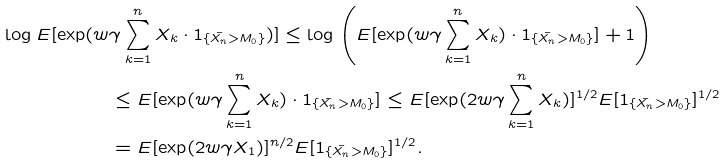Convert formula to latex. <formula><loc_0><loc_0><loc_500><loc_500>\log E [ \exp ( w & \gamma \sum _ { k = 1 } ^ { n } X _ { k } \cdot 1 _ { \{ \bar { X _ { n } } > M _ { 0 } \} } ) ] \leq \log \left ( E [ \exp ( w \gamma \sum _ { k = 1 } ^ { n } X _ { k } ) \cdot 1 _ { \{ \bar { X _ { n } } > M _ { 0 } \} } ] + 1 \right ) \\ & \leq E [ \exp ( w \gamma \sum _ { k = 1 } ^ { n } X _ { k } ) \cdot 1 _ { \{ \bar { X _ { n } } > M _ { 0 } \} } ] \leq E [ \exp ( 2 w \gamma \sum _ { k = 1 } ^ { n } X _ { k } ) ] ^ { 1 / 2 } E [ 1 _ { \{ \bar { X _ { n } } > M _ { 0 } \} } ] ^ { 1 / 2 } \\ & = E [ \exp ( 2 w \gamma X _ { 1 } ) ] ^ { n / 2 } E [ 1 _ { \{ \bar { X _ { n } } > M _ { 0 } \} } ] ^ { 1 / 2 } .</formula> 